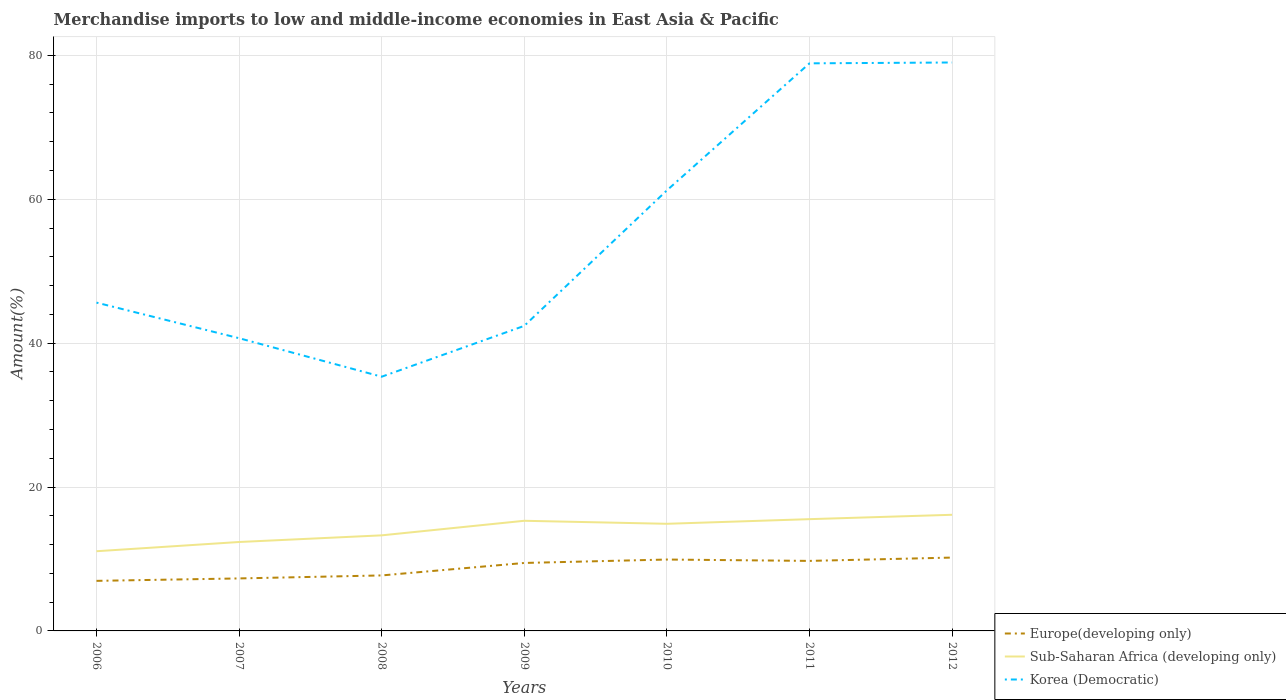How many different coloured lines are there?
Keep it short and to the point. 3. Across all years, what is the maximum percentage of amount earned from merchandise imports in Sub-Saharan Africa (developing only)?
Offer a terse response. 11.08. What is the total percentage of amount earned from merchandise imports in Europe(developing only) in the graph?
Your response must be concise. -2.77. What is the difference between the highest and the second highest percentage of amount earned from merchandise imports in Korea (Democratic)?
Your answer should be very brief. 43.67. What is the difference between the highest and the lowest percentage of amount earned from merchandise imports in Europe(developing only)?
Your answer should be very brief. 4. Is the percentage of amount earned from merchandise imports in Europe(developing only) strictly greater than the percentage of amount earned from merchandise imports in Sub-Saharan Africa (developing only) over the years?
Your answer should be very brief. Yes. How many lines are there?
Provide a short and direct response. 3. How many years are there in the graph?
Keep it short and to the point. 7. Are the values on the major ticks of Y-axis written in scientific E-notation?
Keep it short and to the point. No. Does the graph contain grids?
Your response must be concise. Yes. How many legend labels are there?
Keep it short and to the point. 3. What is the title of the graph?
Ensure brevity in your answer.  Merchandise imports to low and middle-income economies in East Asia & Pacific. Does "Malta" appear as one of the legend labels in the graph?
Offer a terse response. No. What is the label or title of the X-axis?
Provide a succinct answer. Years. What is the label or title of the Y-axis?
Provide a succinct answer. Amount(%). What is the Amount(%) of Europe(developing only) in 2006?
Ensure brevity in your answer.  6.96. What is the Amount(%) of Sub-Saharan Africa (developing only) in 2006?
Your answer should be very brief. 11.08. What is the Amount(%) of Korea (Democratic) in 2006?
Keep it short and to the point. 45.63. What is the Amount(%) of Europe(developing only) in 2007?
Keep it short and to the point. 7.3. What is the Amount(%) of Sub-Saharan Africa (developing only) in 2007?
Offer a terse response. 12.36. What is the Amount(%) of Korea (Democratic) in 2007?
Offer a terse response. 40.68. What is the Amount(%) in Europe(developing only) in 2008?
Your response must be concise. 7.71. What is the Amount(%) of Sub-Saharan Africa (developing only) in 2008?
Your answer should be compact. 13.28. What is the Amount(%) in Korea (Democratic) in 2008?
Make the answer very short. 35.33. What is the Amount(%) in Europe(developing only) in 2009?
Make the answer very short. 9.45. What is the Amount(%) in Sub-Saharan Africa (developing only) in 2009?
Give a very brief answer. 15.31. What is the Amount(%) in Korea (Democratic) in 2009?
Provide a short and direct response. 42.4. What is the Amount(%) in Europe(developing only) in 2010?
Your answer should be very brief. 9.92. What is the Amount(%) of Sub-Saharan Africa (developing only) in 2010?
Give a very brief answer. 14.89. What is the Amount(%) in Korea (Democratic) in 2010?
Offer a terse response. 61.23. What is the Amount(%) of Europe(developing only) in 2011?
Provide a short and direct response. 9.73. What is the Amount(%) in Sub-Saharan Africa (developing only) in 2011?
Make the answer very short. 15.53. What is the Amount(%) in Korea (Democratic) in 2011?
Offer a terse response. 78.89. What is the Amount(%) of Europe(developing only) in 2012?
Your answer should be compact. 10.19. What is the Amount(%) in Sub-Saharan Africa (developing only) in 2012?
Keep it short and to the point. 16.14. What is the Amount(%) in Korea (Democratic) in 2012?
Provide a short and direct response. 79. Across all years, what is the maximum Amount(%) in Europe(developing only)?
Your response must be concise. 10.19. Across all years, what is the maximum Amount(%) in Sub-Saharan Africa (developing only)?
Give a very brief answer. 16.14. Across all years, what is the maximum Amount(%) of Korea (Democratic)?
Your answer should be compact. 79. Across all years, what is the minimum Amount(%) of Europe(developing only)?
Your response must be concise. 6.96. Across all years, what is the minimum Amount(%) in Sub-Saharan Africa (developing only)?
Offer a very short reply. 11.08. Across all years, what is the minimum Amount(%) of Korea (Democratic)?
Provide a short and direct response. 35.33. What is the total Amount(%) of Europe(developing only) in the graph?
Your answer should be very brief. 61.26. What is the total Amount(%) of Sub-Saharan Africa (developing only) in the graph?
Your response must be concise. 98.59. What is the total Amount(%) of Korea (Democratic) in the graph?
Offer a terse response. 383.16. What is the difference between the Amount(%) of Europe(developing only) in 2006 and that in 2007?
Offer a very short reply. -0.34. What is the difference between the Amount(%) of Sub-Saharan Africa (developing only) in 2006 and that in 2007?
Your response must be concise. -1.28. What is the difference between the Amount(%) of Korea (Democratic) in 2006 and that in 2007?
Offer a terse response. 4.95. What is the difference between the Amount(%) of Europe(developing only) in 2006 and that in 2008?
Offer a terse response. -0.75. What is the difference between the Amount(%) of Sub-Saharan Africa (developing only) in 2006 and that in 2008?
Your response must be concise. -2.21. What is the difference between the Amount(%) of Korea (Democratic) in 2006 and that in 2008?
Keep it short and to the point. 10.3. What is the difference between the Amount(%) in Europe(developing only) in 2006 and that in 2009?
Provide a short and direct response. -2.49. What is the difference between the Amount(%) of Sub-Saharan Africa (developing only) in 2006 and that in 2009?
Ensure brevity in your answer.  -4.23. What is the difference between the Amount(%) in Korea (Democratic) in 2006 and that in 2009?
Keep it short and to the point. 3.23. What is the difference between the Amount(%) of Europe(developing only) in 2006 and that in 2010?
Ensure brevity in your answer.  -2.96. What is the difference between the Amount(%) in Sub-Saharan Africa (developing only) in 2006 and that in 2010?
Provide a short and direct response. -3.81. What is the difference between the Amount(%) in Korea (Democratic) in 2006 and that in 2010?
Give a very brief answer. -15.6. What is the difference between the Amount(%) of Europe(developing only) in 2006 and that in 2011?
Give a very brief answer. -2.77. What is the difference between the Amount(%) in Sub-Saharan Africa (developing only) in 2006 and that in 2011?
Provide a succinct answer. -4.46. What is the difference between the Amount(%) of Korea (Democratic) in 2006 and that in 2011?
Give a very brief answer. -33.26. What is the difference between the Amount(%) of Europe(developing only) in 2006 and that in 2012?
Give a very brief answer. -3.24. What is the difference between the Amount(%) in Sub-Saharan Africa (developing only) in 2006 and that in 2012?
Offer a terse response. -5.07. What is the difference between the Amount(%) of Korea (Democratic) in 2006 and that in 2012?
Your answer should be very brief. -33.37. What is the difference between the Amount(%) of Europe(developing only) in 2007 and that in 2008?
Provide a succinct answer. -0.42. What is the difference between the Amount(%) in Sub-Saharan Africa (developing only) in 2007 and that in 2008?
Your answer should be very brief. -0.92. What is the difference between the Amount(%) in Korea (Democratic) in 2007 and that in 2008?
Give a very brief answer. 5.35. What is the difference between the Amount(%) of Europe(developing only) in 2007 and that in 2009?
Your answer should be very brief. -2.15. What is the difference between the Amount(%) of Sub-Saharan Africa (developing only) in 2007 and that in 2009?
Make the answer very short. -2.95. What is the difference between the Amount(%) in Korea (Democratic) in 2007 and that in 2009?
Give a very brief answer. -1.72. What is the difference between the Amount(%) in Europe(developing only) in 2007 and that in 2010?
Offer a terse response. -2.63. What is the difference between the Amount(%) of Sub-Saharan Africa (developing only) in 2007 and that in 2010?
Offer a terse response. -2.53. What is the difference between the Amount(%) of Korea (Democratic) in 2007 and that in 2010?
Your answer should be compact. -20.54. What is the difference between the Amount(%) of Europe(developing only) in 2007 and that in 2011?
Your response must be concise. -2.44. What is the difference between the Amount(%) in Sub-Saharan Africa (developing only) in 2007 and that in 2011?
Provide a short and direct response. -3.17. What is the difference between the Amount(%) in Korea (Democratic) in 2007 and that in 2011?
Offer a terse response. -38.2. What is the difference between the Amount(%) of Europe(developing only) in 2007 and that in 2012?
Ensure brevity in your answer.  -2.9. What is the difference between the Amount(%) of Sub-Saharan Africa (developing only) in 2007 and that in 2012?
Give a very brief answer. -3.78. What is the difference between the Amount(%) in Korea (Democratic) in 2007 and that in 2012?
Make the answer very short. -38.32. What is the difference between the Amount(%) of Europe(developing only) in 2008 and that in 2009?
Offer a very short reply. -1.73. What is the difference between the Amount(%) in Sub-Saharan Africa (developing only) in 2008 and that in 2009?
Offer a terse response. -2.02. What is the difference between the Amount(%) in Korea (Democratic) in 2008 and that in 2009?
Ensure brevity in your answer.  -7.07. What is the difference between the Amount(%) in Europe(developing only) in 2008 and that in 2010?
Give a very brief answer. -2.21. What is the difference between the Amount(%) in Sub-Saharan Africa (developing only) in 2008 and that in 2010?
Ensure brevity in your answer.  -1.61. What is the difference between the Amount(%) in Korea (Democratic) in 2008 and that in 2010?
Provide a short and direct response. -25.9. What is the difference between the Amount(%) in Europe(developing only) in 2008 and that in 2011?
Provide a succinct answer. -2.02. What is the difference between the Amount(%) in Sub-Saharan Africa (developing only) in 2008 and that in 2011?
Your response must be concise. -2.25. What is the difference between the Amount(%) in Korea (Democratic) in 2008 and that in 2011?
Keep it short and to the point. -43.55. What is the difference between the Amount(%) of Europe(developing only) in 2008 and that in 2012?
Give a very brief answer. -2.48. What is the difference between the Amount(%) of Sub-Saharan Africa (developing only) in 2008 and that in 2012?
Your response must be concise. -2.86. What is the difference between the Amount(%) in Korea (Democratic) in 2008 and that in 2012?
Your answer should be very brief. -43.67. What is the difference between the Amount(%) in Europe(developing only) in 2009 and that in 2010?
Make the answer very short. -0.48. What is the difference between the Amount(%) in Sub-Saharan Africa (developing only) in 2009 and that in 2010?
Your answer should be compact. 0.42. What is the difference between the Amount(%) of Korea (Democratic) in 2009 and that in 2010?
Offer a terse response. -18.83. What is the difference between the Amount(%) in Europe(developing only) in 2009 and that in 2011?
Give a very brief answer. -0.29. What is the difference between the Amount(%) in Sub-Saharan Africa (developing only) in 2009 and that in 2011?
Make the answer very short. -0.23. What is the difference between the Amount(%) of Korea (Democratic) in 2009 and that in 2011?
Your answer should be compact. -36.49. What is the difference between the Amount(%) in Europe(developing only) in 2009 and that in 2012?
Keep it short and to the point. -0.75. What is the difference between the Amount(%) of Sub-Saharan Africa (developing only) in 2009 and that in 2012?
Your answer should be compact. -0.83. What is the difference between the Amount(%) in Korea (Democratic) in 2009 and that in 2012?
Keep it short and to the point. -36.6. What is the difference between the Amount(%) in Europe(developing only) in 2010 and that in 2011?
Give a very brief answer. 0.19. What is the difference between the Amount(%) in Sub-Saharan Africa (developing only) in 2010 and that in 2011?
Provide a short and direct response. -0.64. What is the difference between the Amount(%) of Korea (Democratic) in 2010 and that in 2011?
Keep it short and to the point. -17.66. What is the difference between the Amount(%) in Europe(developing only) in 2010 and that in 2012?
Provide a short and direct response. -0.27. What is the difference between the Amount(%) in Sub-Saharan Africa (developing only) in 2010 and that in 2012?
Your answer should be compact. -1.25. What is the difference between the Amount(%) of Korea (Democratic) in 2010 and that in 2012?
Your response must be concise. -17.77. What is the difference between the Amount(%) of Europe(developing only) in 2011 and that in 2012?
Provide a succinct answer. -0.46. What is the difference between the Amount(%) in Sub-Saharan Africa (developing only) in 2011 and that in 2012?
Give a very brief answer. -0.61. What is the difference between the Amount(%) in Korea (Democratic) in 2011 and that in 2012?
Your answer should be compact. -0.12. What is the difference between the Amount(%) of Europe(developing only) in 2006 and the Amount(%) of Sub-Saharan Africa (developing only) in 2007?
Provide a succinct answer. -5.4. What is the difference between the Amount(%) in Europe(developing only) in 2006 and the Amount(%) in Korea (Democratic) in 2007?
Keep it short and to the point. -33.73. What is the difference between the Amount(%) of Sub-Saharan Africa (developing only) in 2006 and the Amount(%) of Korea (Democratic) in 2007?
Offer a terse response. -29.61. What is the difference between the Amount(%) of Europe(developing only) in 2006 and the Amount(%) of Sub-Saharan Africa (developing only) in 2008?
Make the answer very short. -6.33. What is the difference between the Amount(%) in Europe(developing only) in 2006 and the Amount(%) in Korea (Democratic) in 2008?
Provide a short and direct response. -28.37. What is the difference between the Amount(%) in Sub-Saharan Africa (developing only) in 2006 and the Amount(%) in Korea (Democratic) in 2008?
Make the answer very short. -24.26. What is the difference between the Amount(%) of Europe(developing only) in 2006 and the Amount(%) of Sub-Saharan Africa (developing only) in 2009?
Make the answer very short. -8.35. What is the difference between the Amount(%) in Europe(developing only) in 2006 and the Amount(%) in Korea (Democratic) in 2009?
Keep it short and to the point. -35.44. What is the difference between the Amount(%) of Sub-Saharan Africa (developing only) in 2006 and the Amount(%) of Korea (Democratic) in 2009?
Make the answer very short. -31.32. What is the difference between the Amount(%) in Europe(developing only) in 2006 and the Amount(%) in Sub-Saharan Africa (developing only) in 2010?
Offer a terse response. -7.93. What is the difference between the Amount(%) in Europe(developing only) in 2006 and the Amount(%) in Korea (Democratic) in 2010?
Your response must be concise. -54.27. What is the difference between the Amount(%) of Sub-Saharan Africa (developing only) in 2006 and the Amount(%) of Korea (Democratic) in 2010?
Your answer should be compact. -50.15. What is the difference between the Amount(%) in Europe(developing only) in 2006 and the Amount(%) in Sub-Saharan Africa (developing only) in 2011?
Make the answer very short. -8.57. What is the difference between the Amount(%) in Europe(developing only) in 2006 and the Amount(%) in Korea (Democratic) in 2011?
Ensure brevity in your answer.  -71.93. What is the difference between the Amount(%) of Sub-Saharan Africa (developing only) in 2006 and the Amount(%) of Korea (Democratic) in 2011?
Ensure brevity in your answer.  -67.81. What is the difference between the Amount(%) of Europe(developing only) in 2006 and the Amount(%) of Sub-Saharan Africa (developing only) in 2012?
Your response must be concise. -9.18. What is the difference between the Amount(%) in Europe(developing only) in 2006 and the Amount(%) in Korea (Democratic) in 2012?
Your answer should be very brief. -72.04. What is the difference between the Amount(%) of Sub-Saharan Africa (developing only) in 2006 and the Amount(%) of Korea (Democratic) in 2012?
Provide a succinct answer. -67.93. What is the difference between the Amount(%) of Europe(developing only) in 2007 and the Amount(%) of Sub-Saharan Africa (developing only) in 2008?
Your answer should be very brief. -5.99. What is the difference between the Amount(%) in Europe(developing only) in 2007 and the Amount(%) in Korea (Democratic) in 2008?
Your response must be concise. -28.04. What is the difference between the Amount(%) in Sub-Saharan Africa (developing only) in 2007 and the Amount(%) in Korea (Democratic) in 2008?
Offer a very short reply. -22.97. What is the difference between the Amount(%) of Europe(developing only) in 2007 and the Amount(%) of Sub-Saharan Africa (developing only) in 2009?
Provide a short and direct response. -8.01. What is the difference between the Amount(%) in Europe(developing only) in 2007 and the Amount(%) in Korea (Democratic) in 2009?
Make the answer very short. -35.1. What is the difference between the Amount(%) of Sub-Saharan Africa (developing only) in 2007 and the Amount(%) of Korea (Democratic) in 2009?
Keep it short and to the point. -30.04. What is the difference between the Amount(%) in Europe(developing only) in 2007 and the Amount(%) in Sub-Saharan Africa (developing only) in 2010?
Your answer should be compact. -7.59. What is the difference between the Amount(%) in Europe(developing only) in 2007 and the Amount(%) in Korea (Democratic) in 2010?
Offer a terse response. -53.93. What is the difference between the Amount(%) in Sub-Saharan Africa (developing only) in 2007 and the Amount(%) in Korea (Democratic) in 2010?
Your response must be concise. -48.87. What is the difference between the Amount(%) of Europe(developing only) in 2007 and the Amount(%) of Sub-Saharan Africa (developing only) in 2011?
Provide a short and direct response. -8.24. What is the difference between the Amount(%) of Europe(developing only) in 2007 and the Amount(%) of Korea (Democratic) in 2011?
Make the answer very short. -71.59. What is the difference between the Amount(%) in Sub-Saharan Africa (developing only) in 2007 and the Amount(%) in Korea (Democratic) in 2011?
Ensure brevity in your answer.  -66.53. What is the difference between the Amount(%) in Europe(developing only) in 2007 and the Amount(%) in Sub-Saharan Africa (developing only) in 2012?
Provide a succinct answer. -8.85. What is the difference between the Amount(%) of Europe(developing only) in 2007 and the Amount(%) of Korea (Democratic) in 2012?
Keep it short and to the point. -71.71. What is the difference between the Amount(%) of Sub-Saharan Africa (developing only) in 2007 and the Amount(%) of Korea (Democratic) in 2012?
Provide a succinct answer. -66.64. What is the difference between the Amount(%) of Europe(developing only) in 2008 and the Amount(%) of Sub-Saharan Africa (developing only) in 2009?
Provide a succinct answer. -7.59. What is the difference between the Amount(%) in Europe(developing only) in 2008 and the Amount(%) in Korea (Democratic) in 2009?
Provide a short and direct response. -34.69. What is the difference between the Amount(%) of Sub-Saharan Africa (developing only) in 2008 and the Amount(%) of Korea (Democratic) in 2009?
Offer a very short reply. -29.12. What is the difference between the Amount(%) in Europe(developing only) in 2008 and the Amount(%) in Sub-Saharan Africa (developing only) in 2010?
Ensure brevity in your answer.  -7.18. What is the difference between the Amount(%) of Europe(developing only) in 2008 and the Amount(%) of Korea (Democratic) in 2010?
Keep it short and to the point. -53.52. What is the difference between the Amount(%) of Sub-Saharan Africa (developing only) in 2008 and the Amount(%) of Korea (Democratic) in 2010?
Provide a short and direct response. -47.94. What is the difference between the Amount(%) in Europe(developing only) in 2008 and the Amount(%) in Sub-Saharan Africa (developing only) in 2011?
Give a very brief answer. -7.82. What is the difference between the Amount(%) in Europe(developing only) in 2008 and the Amount(%) in Korea (Democratic) in 2011?
Provide a succinct answer. -71.17. What is the difference between the Amount(%) of Sub-Saharan Africa (developing only) in 2008 and the Amount(%) of Korea (Democratic) in 2011?
Give a very brief answer. -65.6. What is the difference between the Amount(%) in Europe(developing only) in 2008 and the Amount(%) in Sub-Saharan Africa (developing only) in 2012?
Provide a succinct answer. -8.43. What is the difference between the Amount(%) in Europe(developing only) in 2008 and the Amount(%) in Korea (Democratic) in 2012?
Give a very brief answer. -71.29. What is the difference between the Amount(%) of Sub-Saharan Africa (developing only) in 2008 and the Amount(%) of Korea (Democratic) in 2012?
Offer a terse response. -65.72. What is the difference between the Amount(%) of Europe(developing only) in 2009 and the Amount(%) of Sub-Saharan Africa (developing only) in 2010?
Provide a succinct answer. -5.44. What is the difference between the Amount(%) in Europe(developing only) in 2009 and the Amount(%) in Korea (Democratic) in 2010?
Keep it short and to the point. -51.78. What is the difference between the Amount(%) in Sub-Saharan Africa (developing only) in 2009 and the Amount(%) in Korea (Democratic) in 2010?
Provide a short and direct response. -45.92. What is the difference between the Amount(%) in Europe(developing only) in 2009 and the Amount(%) in Sub-Saharan Africa (developing only) in 2011?
Offer a very short reply. -6.09. What is the difference between the Amount(%) in Europe(developing only) in 2009 and the Amount(%) in Korea (Democratic) in 2011?
Offer a terse response. -69.44. What is the difference between the Amount(%) in Sub-Saharan Africa (developing only) in 2009 and the Amount(%) in Korea (Democratic) in 2011?
Give a very brief answer. -63.58. What is the difference between the Amount(%) in Europe(developing only) in 2009 and the Amount(%) in Sub-Saharan Africa (developing only) in 2012?
Your answer should be compact. -6.7. What is the difference between the Amount(%) of Europe(developing only) in 2009 and the Amount(%) of Korea (Democratic) in 2012?
Your answer should be very brief. -69.56. What is the difference between the Amount(%) in Sub-Saharan Africa (developing only) in 2009 and the Amount(%) in Korea (Democratic) in 2012?
Your answer should be very brief. -63.7. What is the difference between the Amount(%) in Europe(developing only) in 2010 and the Amount(%) in Sub-Saharan Africa (developing only) in 2011?
Make the answer very short. -5.61. What is the difference between the Amount(%) of Europe(developing only) in 2010 and the Amount(%) of Korea (Democratic) in 2011?
Give a very brief answer. -68.96. What is the difference between the Amount(%) in Sub-Saharan Africa (developing only) in 2010 and the Amount(%) in Korea (Democratic) in 2011?
Offer a very short reply. -64. What is the difference between the Amount(%) of Europe(developing only) in 2010 and the Amount(%) of Sub-Saharan Africa (developing only) in 2012?
Provide a succinct answer. -6.22. What is the difference between the Amount(%) of Europe(developing only) in 2010 and the Amount(%) of Korea (Democratic) in 2012?
Make the answer very short. -69.08. What is the difference between the Amount(%) of Sub-Saharan Africa (developing only) in 2010 and the Amount(%) of Korea (Democratic) in 2012?
Your response must be concise. -64.11. What is the difference between the Amount(%) in Europe(developing only) in 2011 and the Amount(%) in Sub-Saharan Africa (developing only) in 2012?
Keep it short and to the point. -6.41. What is the difference between the Amount(%) of Europe(developing only) in 2011 and the Amount(%) of Korea (Democratic) in 2012?
Offer a very short reply. -69.27. What is the difference between the Amount(%) of Sub-Saharan Africa (developing only) in 2011 and the Amount(%) of Korea (Democratic) in 2012?
Make the answer very short. -63.47. What is the average Amount(%) of Europe(developing only) per year?
Make the answer very short. 8.75. What is the average Amount(%) of Sub-Saharan Africa (developing only) per year?
Offer a terse response. 14.08. What is the average Amount(%) in Korea (Democratic) per year?
Keep it short and to the point. 54.74. In the year 2006, what is the difference between the Amount(%) of Europe(developing only) and Amount(%) of Sub-Saharan Africa (developing only)?
Ensure brevity in your answer.  -4.12. In the year 2006, what is the difference between the Amount(%) in Europe(developing only) and Amount(%) in Korea (Democratic)?
Your answer should be compact. -38.67. In the year 2006, what is the difference between the Amount(%) in Sub-Saharan Africa (developing only) and Amount(%) in Korea (Democratic)?
Make the answer very short. -34.55. In the year 2007, what is the difference between the Amount(%) of Europe(developing only) and Amount(%) of Sub-Saharan Africa (developing only)?
Give a very brief answer. -5.06. In the year 2007, what is the difference between the Amount(%) in Europe(developing only) and Amount(%) in Korea (Democratic)?
Offer a very short reply. -33.39. In the year 2007, what is the difference between the Amount(%) of Sub-Saharan Africa (developing only) and Amount(%) of Korea (Democratic)?
Your response must be concise. -28.32. In the year 2008, what is the difference between the Amount(%) in Europe(developing only) and Amount(%) in Sub-Saharan Africa (developing only)?
Make the answer very short. -5.57. In the year 2008, what is the difference between the Amount(%) of Europe(developing only) and Amount(%) of Korea (Democratic)?
Your response must be concise. -27.62. In the year 2008, what is the difference between the Amount(%) of Sub-Saharan Africa (developing only) and Amount(%) of Korea (Democratic)?
Make the answer very short. -22.05. In the year 2009, what is the difference between the Amount(%) in Europe(developing only) and Amount(%) in Sub-Saharan Africa (developing only)?
Offer a very short reply. -5.86. In the year 2009, what is the difference between the Amount(%) in Europe(developing only) and Amount(%) in Korea (Democratic)?
Make the answer very short. -32.95. In the year 2009, what is the difference between the Amount(%) of Sub-Saharan Africa (developing only) and Amount(%) of Korea (Democratic)?
Ensure brevity in your answer.  -27.09. In the year 2010, what is the difference between the Amount(%) of Europe(developing only) and Amount(%) of Sub-Saharan Africa (developing only)?
Your answer should be compact. -4.97. In the year 2010, what is the difference between the Amount(%) in Europe(developing only) and Amount(%) in Korea (Democratic)?
Your answer should be compact. -51.31. In the year 2010, what is the difference between the Amount(%) in Sub-Saharan Africa (developing only) and Amount(%) in Korea (Democratic)?
Make the answer very short. -46.34. In the year 2011, what is the difference between the Amount(%) of Europe(developing only) and Amount(%) of Sub-Saharan Africa (developing only)?
Offer a terse response. -5.8. In the year 2011, what is the difference between the Amount(%) in Europe(developing only) and Amount(%) in Korea (Democratic)?
Provide a succinct answer. -69.15. In the year 2011, what is the difference between the Amount(%) in Sub-Saharan Africa (developing only) and Amount(%) in Korea (Democratic)?
Keep it short and to the point. -63.35. In the year 2012, what is the difference between the Amount(%) of Europe(developing only) and Amount(%) of Sub-Saharan Africa (developing only)?
Offer a terse response. -5.95. In the year 2012, what is the difference between the Amount(%) in Europe(developing only) and Amount(%) in Korea (Democratic)?
Give a very brief answer. -68.81. In the year 2012, what is the difference between the Amount(%) of Sub-Saharan Africa (developing only) and Amount(%) of Korea (Democratic)?
Your answer should be compact. -62.86. What is the ratio of the Amount(%) of Europe(developing only) in 2006 to that in 2007?
Your answer should be very brief. 0.95. What is the ratio of the Amount(%) of Sub-Saharan Africa (developing only) in 2006 to that in 2007?
Keep it short and to the point. 0.9. What is the ratio of the Amount(%) in Korea (Democratic) in 2006 to that in 2007?
Your answer should be very brief. 1.12. What is the ratio of the Amount(%) of Europe(developing only) in 2006 to that in 2008?
Ensure brevity in your answer.  0.9. What is the ratio of the Amount(%) of Sub-Saharan Africa (developing only) in 2006 to that in 2008?
Your answer should be very brief. 0.83. What is the ratio of the Amount(%) in Korea (Democratic) in 2006 to that in 2008?
Keep it short and to the point. 1.29. What is the ratio of the Amount(%) in Europe(developing only) in 2006 to that in 2009?
Your answer should be compact. 0.74. What is the ratio of the Amount(%) in Sub-Saharan Africa (developing only) in 2006 to that in 2009?
Offer a terse response. 0.72. What is the ratio of the Amount(%) of Korea (Democratic) in 2006 to that in 2009?
Provide a short and direct response. 1.08. What is the ratio of the Amount(%) in Europe(developing only) in 2006 to that in 2010?
Provide a succinct answer. 0.7. What is the ratio of the Amount(%) of Sub-Saharan Africa (developing only) in 2006 to that in 2010?
Provide a succinct answer. 0.74. What is the ratio of the Amount(%) in Korea (Democratic) in 2006 to that in 2010?
Your answer should be compact. 0.75. What is the ratio of the Amount(%) in Europe(developing only) in 2006 to that in 2011?
Offer a terse response. 0.72. What is the ratio of the Amount(%) in Sub-Saharan Africa (developing only) in 2006 to that in 2011?
Ensure brevity in your answer.  0.71. What is the ratio of the Amount(%) in Korea (Democratic) in 2006 to that in 2011?
Ensure brevity in your answer.  0.58. What is the ratio of the Amount(%) in Europe(developing only) in 2006 to that in 2012?
Your answer should be compact. 0.68. What is the ratio of the Amount(%) of Sub-Saharan Africa (developing only) in 2006 to that in 2012?
Make the answer very short. 0.69. What is the ratio of the Amount(%) of Korea (Democratic) in 2006 to that in 2012?
Your answer should be very brief. 0.58. What is the ratio of the Amount(%) of Europe(developing only) in 2007 to that in 2008?
Your answer should be compact. 0.95. What is the ratio of the Amount(%) of Sub-Saharan Africa (developing only) in 2007 to that in 2008?
Make the answer very short. 0.93. What is the ratio of the Amount(%) of Korea (Democratic) in 2007 to that in 2008?
Provide a short and direct response. 1.15. What is the ratio of the Amount(%) in Europe(developing only) in 2007 to that in 2009?
Provide a short and direct response. 0.77. What is the ratio of the Amount(%) in Sub-Saharan Africa (developing only) in 2007 to that in 2009?
Offer a terse response. 0.81. What is the ratio of the Amount(%) in Korea (Democratic) in 2007 to that in 2009?
Your answer should be very brief. 0.96. What is the ratio of the Amount(%) of Europe(developing only) in 2007 to that in 2010?
Keep it short and to the point. 0.74. What is the ratio of the Amount(%) in Sub-Saharan Africa (developing only) in 2007 to that in 2010?
Your answer should be compact. 0.83. What is the ratio of the Amount(%) in Korea (Democratic) in 2007 to that in 2010?
Provide a short and direct response. 0.66. What is the ratio of the Amount(%) of Europe(developing only) in 2007 to that in 2011?
Offer a terse response. 0.75. What is the ratio of the Amount(%) of Sub-Saharan Africa (developing only) in 2007 to that in 2011?
Your response must be concise. 0.8. What is the ratio of the Amount(%) in Korea (Democratic) in 2007 to that in 2011?
Keep it short and to the point. 0.52. What is the ratio of the Amount(%) of Europe(developing only) in 2007 to that in 2012?
Your answer should be very brief. 0.72. What is the ratio of the Amount(%) in Sub-Saharan Africa (developing only) in 2007 to that in 2012?
Ensure brevity in your answer.  0.77. What is the ratio of the Amount(%) of Korea (Democratic) in 2007 to that in 2012?
Keep it short and to the point. 0.52. What is the ratio of the Amount(%) of Europe(developing only) in 2008 to that in 2009?
Make the answer very short. 0.82. What is the ratio of the Amount(%) of Sub-Saharan Africa (developing only) in 2008 to that in 2009?
Offer a very short reply. 0.87. What is the ratio of the Amount(%) of Europe(developing only) in 2008 to that in 2010?
Offer a very short reply. 0.78. What is the ratio of the Amount(%) of Sub-Saharan Africa (developing only) in 2008 to that in 2010?
Make the answer very short. 0.89. What is the ratio of the Amount(%) of Korea (Democratic) in 2008 to that in 2010?
Ensure brevity in your answer.  0.58. What is the ratio of the Amount(%) of Europe(developing only) in 2008 to that in 2011?
Give a very brief answer. 0.79. What is the ratio of the Amount(%) in Sub-Saharan Africa (developing only) in 2008 to that in 2011?
Offer a terse response. 0.86. What is the ratio of the Amount(%) in Korea (Democratic) in 2008 to that in 2011?
Offer a very short reply. 0.45. What is the ratio of the Amount(%) of Europe(developing only) in 2008 to that in 2012?
Your answer should be compact. 0.76. What is the ratio of the Amount(%) of Sub-Saharan Africa (developing only) in 2008 to that in 2012?
Make the answer very short. 0.82. What is the ratio of the Amount(%) in Korea (Democratic) in 2008 to that in 2012?
Your answer should be very brief. 0.45. What is the ratio of the Amount(%) of Sub-Saharan Africa (developing only) in 2009 to that in 2010?
Provide a short and direct response. 1.03. What is the ratio of the Amount(%) in Korea (Democratic) in 2009 to that in 2010?
Keep it short and to the point. 0.69. What is the ratio of the Amount(%) in Europe(developing only) in 2009 to that in 2011?
Offer a terse response. 0.97. What is the ratio of the Amount(%) of Sub-Saharan Africa (developing only) in 2009 to that in 2011?
Offer a very short reply. 0.99. What is the ratio of the Amount(%) of Korea (Democratic) in 2009 to that in 2011?
Offer a very short reply. 0.54. What is the ratio of the Amount(%) of Europe(developing only) in 2009 to that in 2012?
Keep it short and to the point. 0.93. What is the ratio of the Amount(%) in Sub-Saharan Africa (developing only) in 2009 to that in 2012?
Your answer should be very brief. 0.95. What is the ratio of the Amount(%) of Korea (Democratic) in 2009 to that in 2012?
Offer a terse response. 0.54. What is the ratio of the Amount(%) in Europe(developing only) in 2010 to that in 2011?
Offer a terse response. 1.02. What is the ratio of the Amount(%) in Sub-Saharan Africa (developing only) in 2010 to that in 2011?
Your answer should be very brief. 0.96. What is the ratio of the Amount(%) in Korea (Democratic) in 2010 to that in 2011?
Provide a succinct answer. 0.78. What is the ratio of the Amount(%) of Europe(developing only) in 2010 to that in 2012?
Make the answer very short. 0.97. What is the ratio of the Amount(%) in Sub-Saharan Africa (developing only) in 2010 to that in 2012?
Ensure brevity in your answer.  0.92. What is the ratio of the Amount(%) of Korea (Democratic) in 2010 to that in 2012?
Your answer should be compact. 0.78. What is the ratio of the Amount(%) of Europe(developing only) in 2011 to that in 2012?
Your answer should be compact. 0.95. What is the ratio of the Amount(%) of Sub-Saharan Africa (developing only) in 2011 to that in 2012?
Offer a terse response. 0.96. What is the difference between the highest and the second highest Amount(%) of Europe(developing only)?
Give a very brief answer. 0.27. What is the difference between the highest and the second highest Amount(%) of Sub-Saharan Africa (developing only)?
Your answer should be very brief. 0.61. What is the difference between the highest and the second highest Amount(%) of Korea (Democratic)?
Offer a very short reply. 0.12. What is the difference between the highest and the lowest Amount(%) of Europe(developing only)?
Keep it short and to the point. 3.24. What is the difference between the highest and the lowest Amount(%) in Sub-Saharan Africa (developing only)?
Ensure brevity in your answer.  5.07. What is the difference between the highest and the lowest Amount(%) of Korea (Democratic)?
Provide a succinct answer. 43.67. 